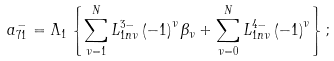<formula> <loc_0><loc_0><loc_500><loc_500>a _ { 7 1 } ^ { - } = \Lambda _ { 1 } \left \{ \sum _ { \nu = 1 } ^ { N } L _ { 1 n \nu } ^ { 3 - } \left ( - 1 \right ) ^ { \nu } \beta _ { \nu } + \sum _ { \nu = 0 } ^ { N } L _ { 1 n \nu } ^ { 4 - } \left ( - 1 \right ) ^ { \nu } \right \} ;</formula> 